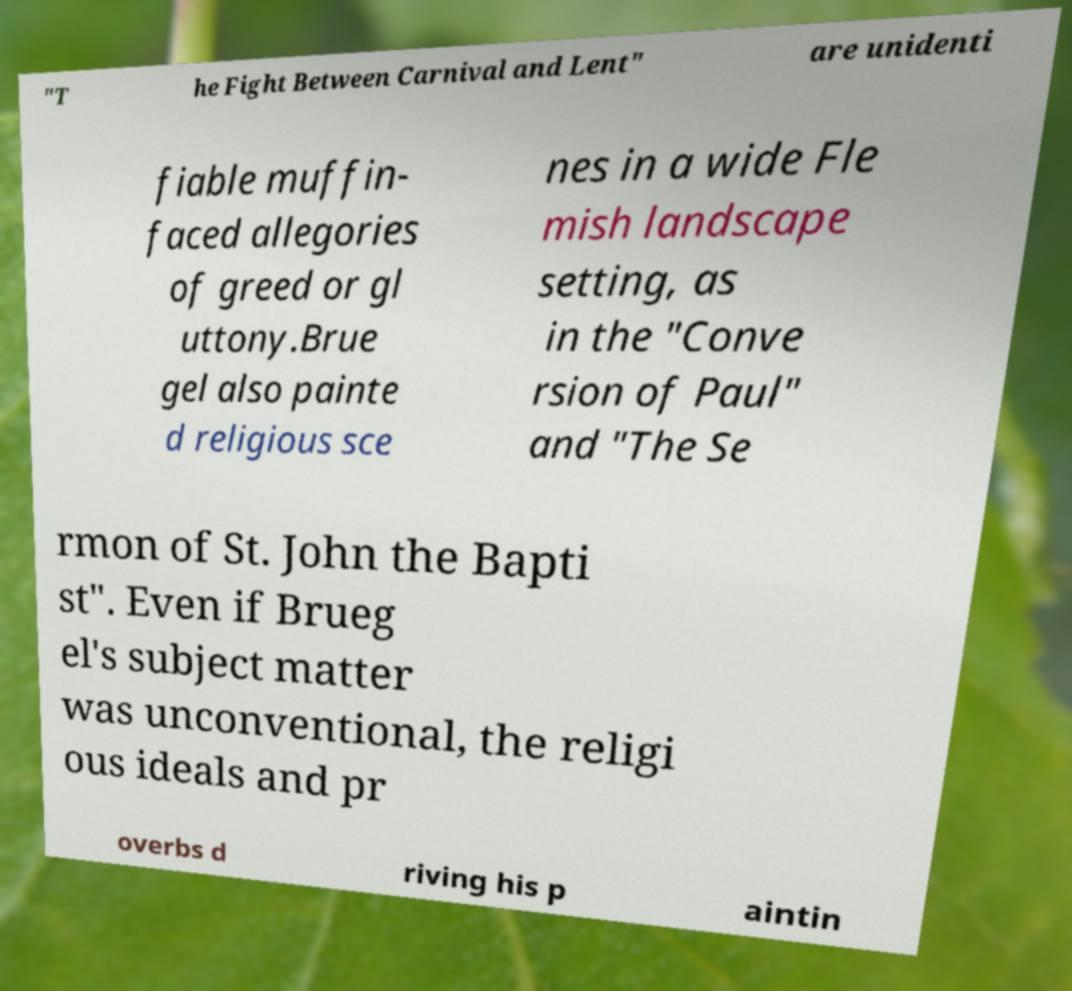Could you extract and type out the text from this image? "T he Fight Between Carnival and Lent" are unidenti fiable muffin- faced allegories of greed or gl uttony.Brue gel also painte d religious sce nes in a wide Fle mish landscape setting, as in the "Conve rsion of Paul" and "The Se rmon of St. John the Bapti st". Even if Brueg el's subject matter was unconventional, the religi ous ideals and pr overbs d riving his p aintin 